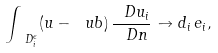Convert formula to latex. <formula><loc_0><loc_0><loc_500><loc_500>\int _ { \ D ^ { \epsilon } _ { i } } ( u - \ u b ) \, \frac { \ D u _ { i } } { \ D n } \to d _ { i } \, e _ { i } ,</formula> 